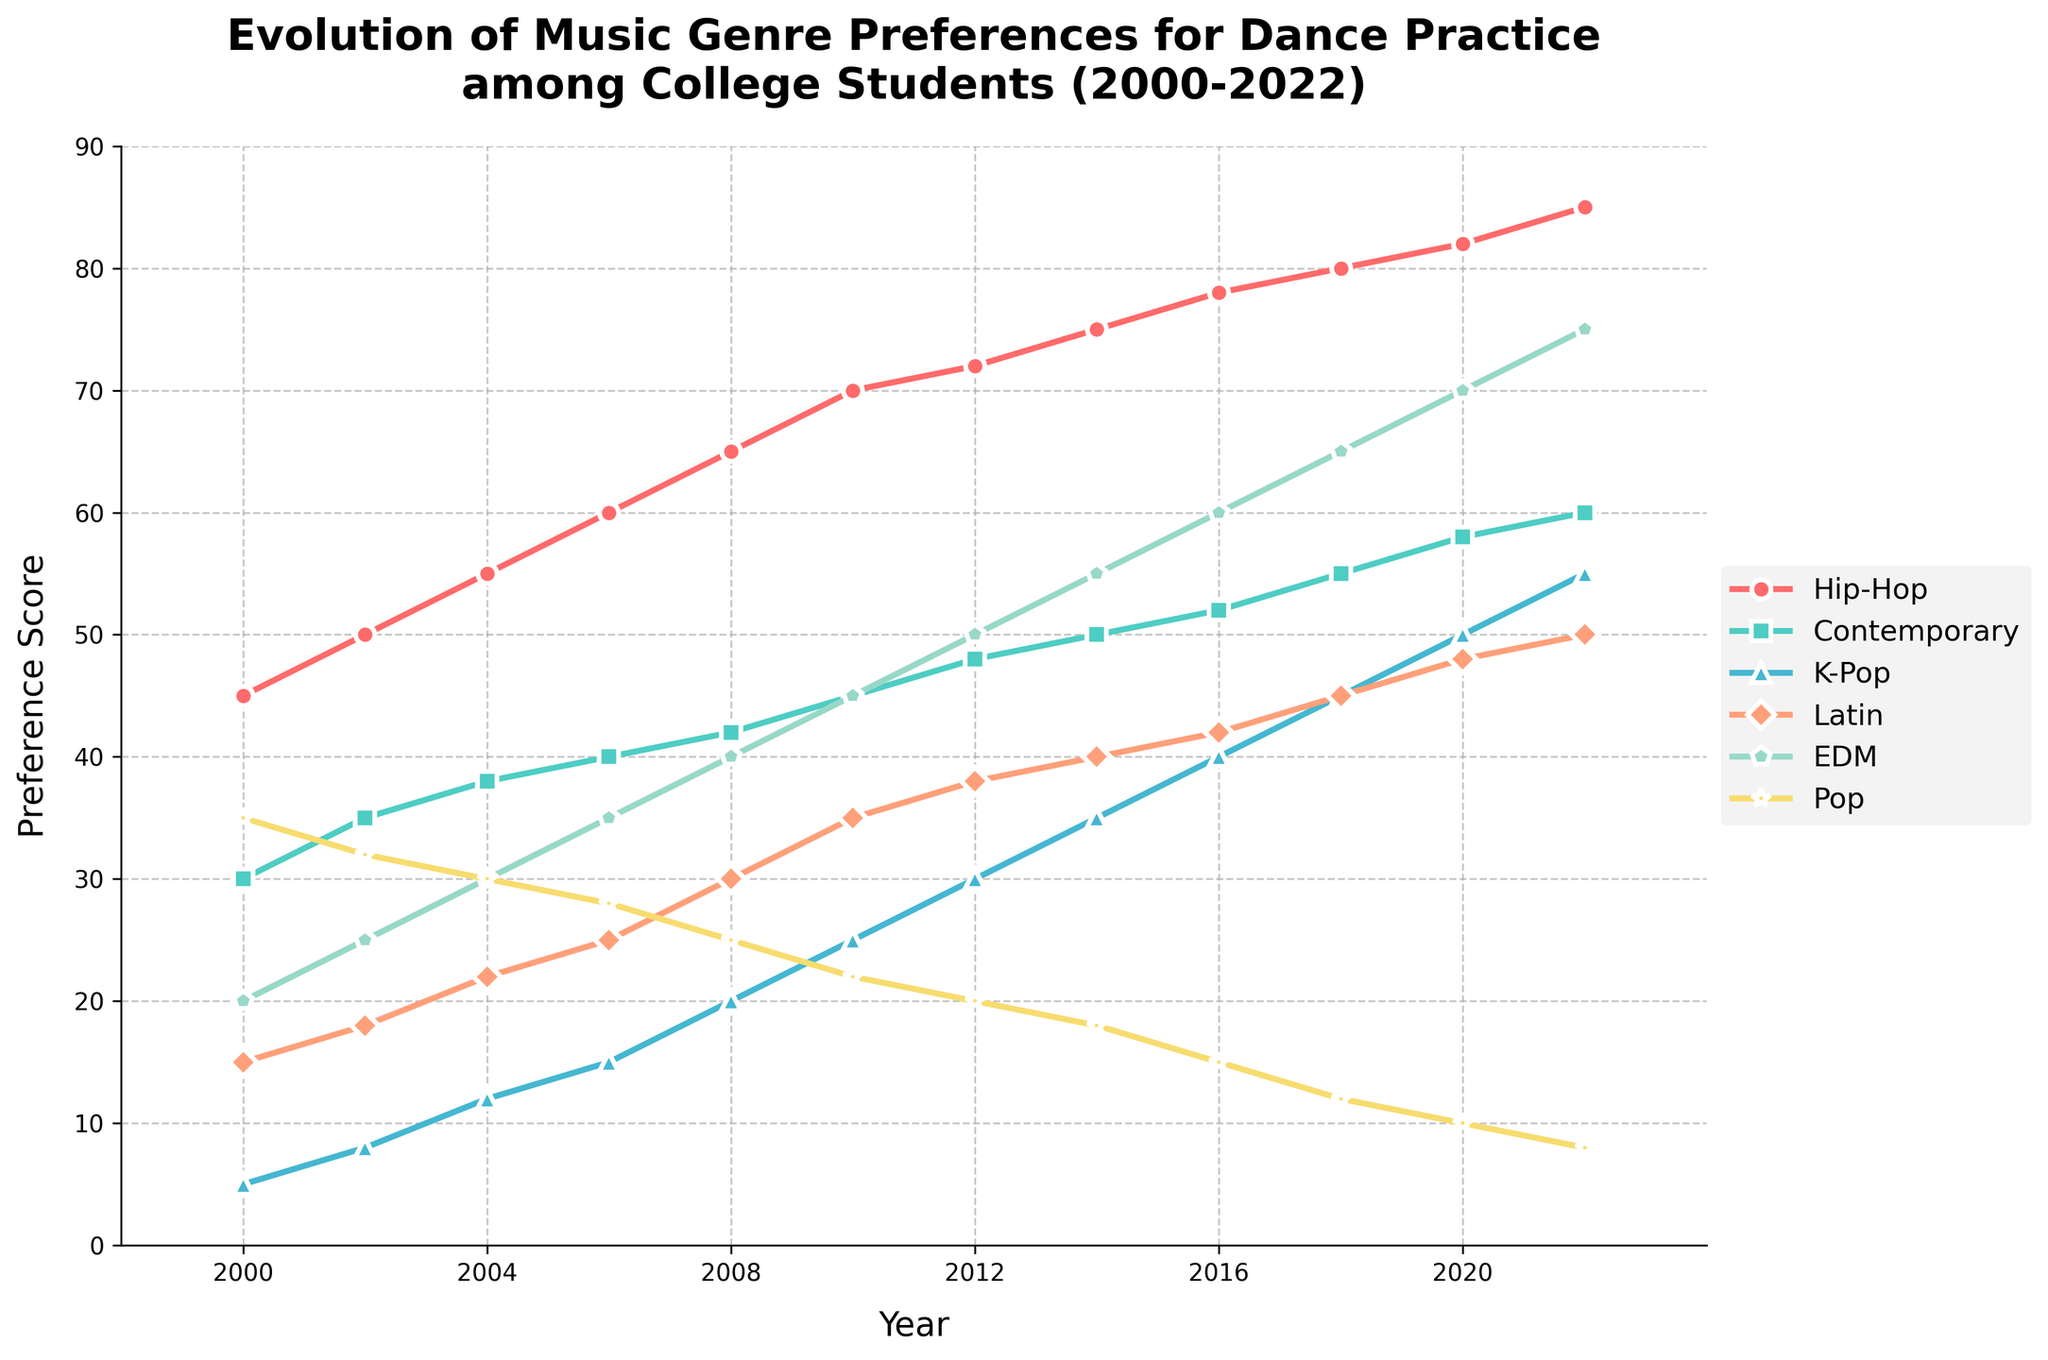Which genre showed the highest preference score in 2022? Referring to the line chart, the genre 'Hip-Hop' has the highest preference score in 2022. It is shown at the top of the chart with a score of 85.
Answer: Hip-Hop What is the difference in the preference score of 'Pop' between 2000 and 2022? According to the figure, 'Pop' had a preference score of 35 in 2000 and 8 in 2022. The difference can be calculated as 35 - 8 = 27.
Answer: 27 Which two genres had a similar trend in a rising preference score throughout the years? Observing the visual trend, 'Hip-Hop' and 'K-Pop' both show a consistent increase in preference scores from 2000 to 2022. Both lines have a clear upward trajectory.
Answer: Hip-Hop and K-Pop Between 'Contemporary' and 'EDM', which genre had a higher preference score in 2010? In 2010, from the figure, 'EDM' showed a preference score around 45, while 'Contemporary' had a score around 45. Thus, 'EDM' and 'Contemporary' had the same preference scores.
Answer: Both What was the average preference score of 'Latin' from 2000 to 2022? The preference scores of 'Latin' from 2000 to 2022 are: 15, 18, 22, 25, 30, 35, 38, 40, 42, 45, 48, 50. The average is (15+18+22+25+30+35+38+40+42+45+48+50)/12 = 32.
Answer: 32 How did the preference for 'K-Pop' change from 2002 to 2012? In 2002, the 'K-Pop' preference score was 8, and it increased to 30 in 2012. The change was 30 - 8 = 22.
Answer: 22 Which genre had the largest increase in preference score from 2000 to 2022? Examining the chart, 'K-Pop' had an increase from 5 in 2000 to 55 in 2022. The increase is 55 - 5 = 50. Compared to other genres, 'K-Pop' had the largest increase.
Answer: K-Pop By how much did the preference score for 'EDM' increase from 2010 to 2018? In 2010, 'EDM' had a preference score of 45, and it increased to 65 in 2018. The increase can be calculated as 65 - 45 = 20.
Answer: 20 